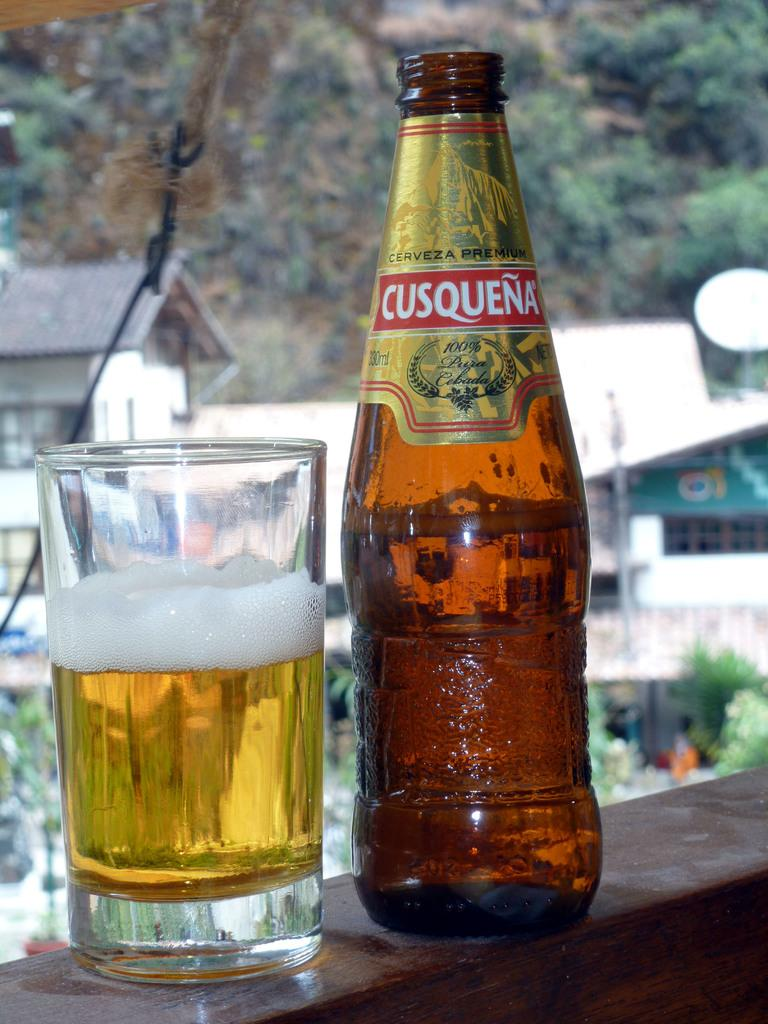What is on the table in the image? There is a bottle and a glass with wine on the table. What can be seen in the distance in the image? There are trees and buildings in the distance. What sense is being used to detect the level of the wine in the glass? The image does not provide information about the sense being used to detect the level of the wine in the glass. 